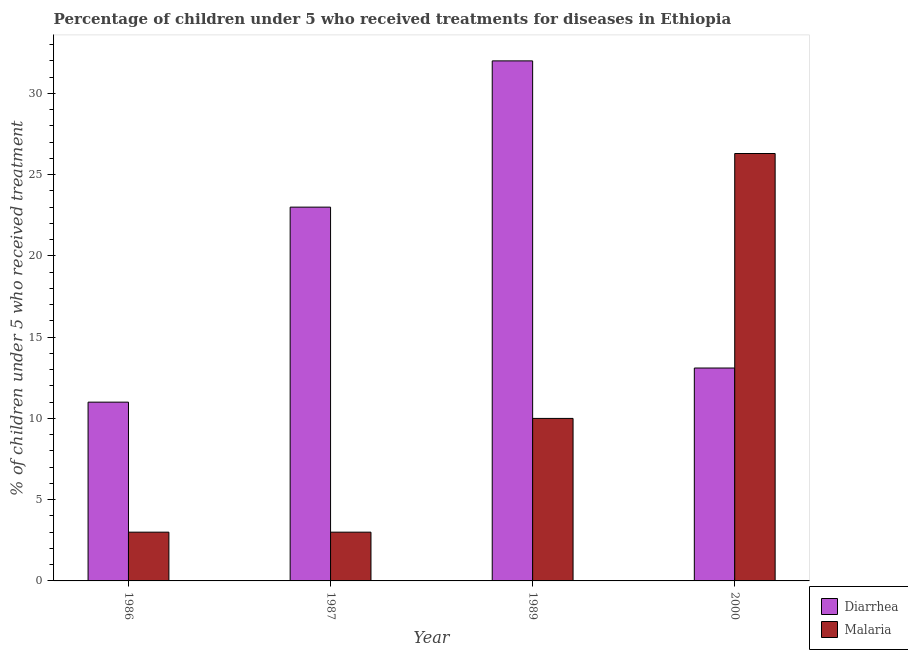How many groups of bars are there?
Keep it short and to the point. 4. Are the number of bars on each tick of the X-axis equal?
Ensure brevity in your answer.  Yes. How many bars are there on the 3rd tick from the left?
Ensure brevity in your answer.  2. Across all years, what is the maximum percentage of children who received treatment for malaria?
Provide a short and direct response. 26.3. In which year was the percentage of children who received treatment for diarrhoea maximum?
Your response must be concise. 1989. What is the total percentage of children who received treatment for diarrhoea in the graph?
Ensure brevity in your answer.  79.1. What is the difference between the percentage of children who received treatment for diarrhoea in 1986 and the percentage of children who received treatment for malaria in 1989?
Offer a terse response. -21. What is the average percentage of children who received treatment for malaria per year?
Keep it short and to the point. 10.57. What is the ratio of the percentage of children who received treatment for malaria in 1989 to that in 2000?
Provide a short and direct response. 0.38. What is the difference between the highest and the lowest percentage of children who received treatment for malaria?
Your answer should be compact. 23.3. In how many years, is the percentage of children who received treatment for diarrhoea greater than the average percentage of children who received treatment for diarrhoea taken over all years?
Your answer should be very brief. 2. What does the 2nd bar from the left in 1987 represents?
Offer a very short reply. Malaria. What does the 2nd bar from the right in 1986 represents?
Ensure brevity in your answer.  Diarrhea. How many years are there in the graph?
Provide a succinct answer. 4. Does the graph contain grids?
Your answer should be very brief. No. How many legend labels are there?
Your answer should be compact. 2. How are the legend labels stacked?
Provide a short and direct response. Vertical. What is the title of the graph?
Your answer should be compact. Percentage of children under 5 who received treatments for diseases in Ethiopia. What is the label or title of the X-axis?
Make the answer very short. Year. What is the label or title of the Y-axis?
Offer a terse response. % of children under 5 who received treatment. What is the % of children under 5 who received treatment in Malaria in 1986?
Your answer should be compact. 3. What is the % of children under 5 who received treatment of Diarrhea in 1987?
Give a very brief answer. 23. What is the % of children under 5 who received treatment of Diarrhea in 1989?
Your response must be concise. 32. What is the % of children under 5 who received treatment in Malaria in 2000?
Your answer should be very brief. 26.3. Across all years, what is the maximum % of children under 5 who received treatment in Malaria?
Offer a very short reply. 26.3. Across all years, what is the minimum % of children under 5 who received treatment in Diarrhea?
Your answer should be very brief. 11. Across all years, what is the minimum % of children under 5 who received treatment of Malaria?
Ensure brevity in your answer.  3. What is the total % of children under 5 who received treatment of Diarrhea in the graph?
Keep it short and to the point. 79.1. What is the total % of children under 5 who received treatment in Malaria in the graph?
Make the answer very short. 42.3. What is the difference between the % of children under 5 who received treatment of Diarrhea in 1986 and that in 1987?
Ensure brevity in your answer.  -12. What is the difference between the % of children under 5 who received treatment in Malaria in 1986 and that in 1987?
Offer a very short reply. 0. What is the difference between the % of children under 5 who received treatment in Malaria in 1986 and that in 1989?
Your answer should be compact. -7. What is the difference between the % of children under 5 who received treatment of Malaria in 1986 and that in 2000?
Give a very brief answer. -23.3. What is the difference between the % of children under 5 who received treatment of Malaria in 1987 and that in 2000?
Offer a very short reply. -23.3. What is the difference between the % of children under 5 who received treatment in Diarrhea in 1989 and that in 2000?
Ensure brevity in your answer.  18.9. What is the difference between the % of children under 5 who received treatment of Malaria in 1989 and that in 2000?
Give a very brief answer. -16.3. What is the difference between the % of children under 5 who received treatment of Diarrhea in 1986 and the % of children under 5 who received treatment of Malaria in 2000?
Offer a very short reply. -15.3. What is the difference between the % of children under 5 who received treatment in Diarrhea in 1987 and the % of children under 5 who received treatment in Malaria in 2000?
Your answer should be compact. -3.3. What is the average % of children under 5 who received treatment in Diarrhea per year?
Give a very brief answer. 19.77. What is the average % of children under 5 who received treatment of Malaria per year?
Your answer should be very brief. 10.57. In the year 1986, what is the difference between the % of children under 5 who received treatment of Diarrhea and % of children under 5 who received treatment of Malaria?
Ensure brevity in your answer.  8. In the year 1987, what is the difference between the % of children under 5 who received treatment of Diarrhea and % of children under 5 who received treatment of Malaria?
Your response must be concise. 20. In the year 1989, what is the difference between the % of children under 5 who received treatment in Diarrhea and % of children under 5 who received treatment in Malaria?
Keep it short and to the point. 22. In the year 2000, what is the difference between the % of children under 5 who received treatment in Diarrhea and % of children under 5 who received treatment in Malaria?
Keep it short and to the point. -13.2. What is the ratio of the % of children under 5 who received treatment of Diarrhea in 1986 to that in 1987?
Offer a terse response. 0.48. What is the ratio of the % of children under 5 who received treatment of Diarrhea in 1986 to that in 1989?
Give a very brief answer. 0.34. What is the ratio of the % of children under 5 who received treatment in Diarrhea in 1986 to that in 2000?
Your answer should be compact. 0.84. What is the ratio of the % of children under 5 who received treatment in Malaria in 1986 to that in 2000?
Your answer should be compact. 0.11. What is the ratio of the % of children under 5 who received treatment of Diarrhea in 1987 to that in 1989?
Ensure brevity in your answer.  0.72. What is the ratio of the % of children under 5 who received treatment in Diarrhea in 1987 to that in 2000?
Your answer should be compact. 1.76. What is the ratio of the % of children under 5 who received treatment of Malaria in 1987 to that in 2000?
Your answer should be compact. 0.11. What is the ratio of the % of children under 5 who received treatment in Diarrhea in 1989 to that in 2000?
Keep it short and to the point. 2.44. What is the ratio of the % of children under 5 who received treatment in Malaria in 1989 to that in 2000?
Your answer should be very brief. 0.38. What is the difference between the highest and the second highest % of children under 5 who received treatment in Malaria?
Keep it short and to the point. 16.3. What is the difference between the highest and the lowest % of children under 5 who received treatment in Diarrhea?
Your response must be concise. 21. What is the difference between the highest and the lowest % of children under 5 who received treatment of Malaria?
Provide a short and direct response. 23.3. 